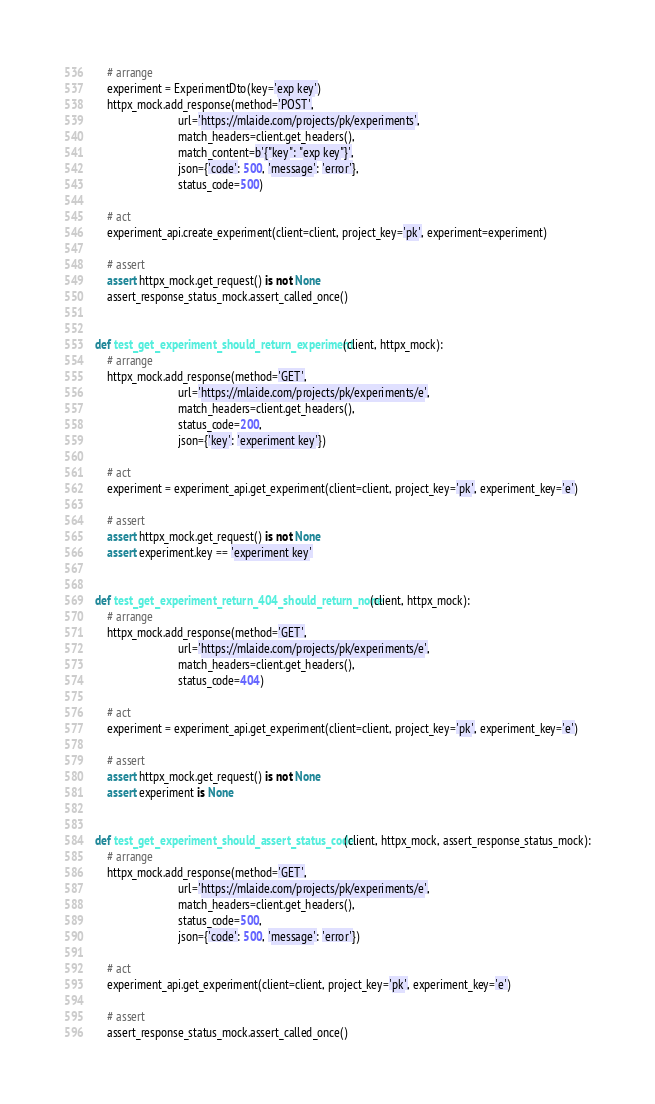<code> <loc_0><loc_0><loc_500><loc_500><_Python_>    # arrange
    experiment = ExperimentDto(key='exp key')
    httpx_mock.add_response(method='POST',
                            url='https://mlaide.com/projects/pk/experiments',
                            match_headers=client.get_headers(),
                            match_content=b'{"key": "exp key"}',
                            json={'code': 500, 'message': 'error'},
                            status_code=500)

    # act
    experiment_api.create_experiment(client=client, project_key='pk', experiment=experiment)

    # assert
    assert httpx_mock.get_request() is not None
    assert_response_status_mock.assert_called_once()


def test_get_experiment_should_return_experiment(client, httpx_mock):
    # arrange
    httpx_mock.add_response(method='GET',
                            url='https://mlaide.com/projects/pk/experiments/e',
                            match_headers=client.get_headers(),
                            status_code=200,
                            json={'key': 'experiment key'})

    # act
    experiment = experiment_api.get_experiment(client=client, project_key='pk', experiment_key='e')

    # assert
    assert httpx_mock.get_request() is not None
    assert experiment.key == 'experiment key'


def test_get_experiment_return_404_should_return_none(client, httpx_mock):
    # arrange
    httpx_mock.add_response(method='GET',
                            url='https://mlaide.com/projects/pk/experiments/e',
                            match_headers=client.get_headers(),
                            status_code=404)

    # act
    experiment = experiment_api.get_experiment(client=client, project_key='pk', experiment_key='e')

    # assert
    assert httpx_mock.get_request() is not None
    assert experiment is None


def test_get_experiment_should_assert_status_code(client, httpx_mock, assert_response_status_mock):
    # arrange
    httpx_mock.add_response(method='GET',
                            url='https://mlaide.com/projects/pk/experiments/e',
                            match_headers=client.get_headers(),
                            status_code=500,
                            json={'code': 500, 'message': 'error'})

    # act
    experiment_api.get_experiment(client=client, project_key='pk', experiment_key='e')

    # assert
    assert_response_status_mock.assert_called_once()
</code> 